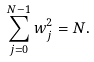<formula> <loc_0><loc_0><loc_500><loc_500>\sum _ { j = 0 } ^ { N - 1 } w _ { j } ^ { 2 } = N .</formula> 